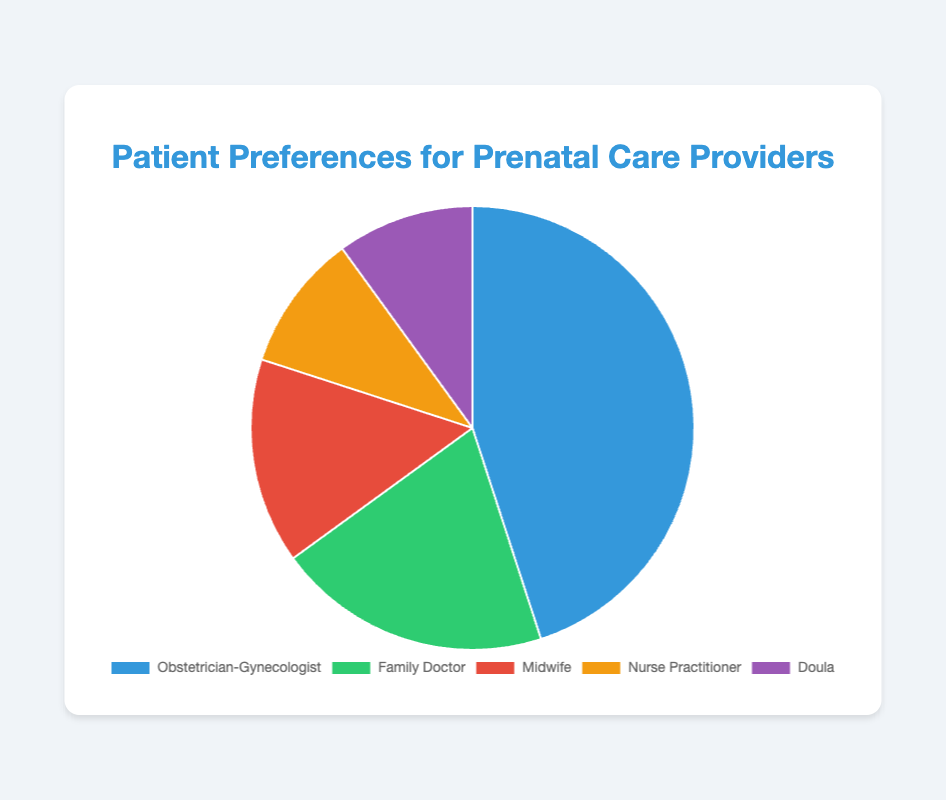Which provider type is preferred by the majority of patients? By observing the pie chart, we can see that the largest segment corresponds to Obstetrician-Gynecologist, which takes up 45%. Hence, most patients prefer Obstetrician-Gynecologists.
Answer: Obstetrician-Gynecologist How many percentage points more prefer an Obstetrician-Gynecologist compared to a Midwife? The pie chart shows 45% preferring an Obstetrician-Gynecologist and 15% preferring a Midwife. Subtracting these values gives 45% - 15% = 30%.
Answer: 30 Combine the percentages of patients preferring Nurse Practitioners and Doulas. Does this combined preference exceed that for Family Doctors? Nurse Practitioners have 10% and Doulas also have 10%. Summing these gives 10% + 10% = 20%. This combined preference equals the 20% for Family Doctors, so it does not exceed.
Answer: No What is the percentage difference between the most and least preferred providers? The most preferred provider is Obstetrician-Gynecologist at 45%, and the least preferred providers are both Nurse Practitioner and Doula at 10%. The difference is 45% - 10% = 35%.
Answer: 35 If a patient doesn't prefer an Obstetrician-Gynecologist, what is the total percentage that they might prefer other providers? The total percentages for Family Doctor, Midwife, Nurse Practitioner, and Doula are 20%, 15%, 10%, and 10% respectively. Summing these gives 20% + 15% + 10% + 10% = 55%.
Answer: 55 Which provider types together account for less than half of the patient preferences? Observing the pie chart, the segments for Midwife (15%), Nurse Practitioner (10%), and Doula (10%) add up to 15% + 10% + 10% = 35%, which is less than 50%.
Answer: Midwife, Nurse Practitioner, Doula What color represents the Family Doctor in the pie chart, and why is it significant for visual interpretation? The Family Doctor is represented by green in the pie chart. This color helps in visually distinguishing it from the other segments, making it easier to quickly identify the respective percentage.
Answer: Green What is the average percentage preference for Midwife, Nurse Practitioner, and Doula? The values for Midwife, Nurse Practitioner, and Doula are 15%, 10%, and 10% respectively. The sum is 15% + 10% + 10% = 35%, and the average is 35%/3 ≈ 11.67%.
Answer: 11.67 